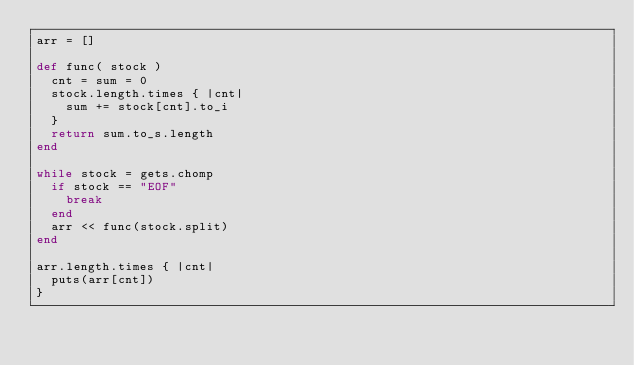<code> <loc_0><loc_0><loc_500><loc_500><_Ruby_>arr = []

def func( stock )
  cnt = sum = 0
  stock.length.times { |cnt|
    sum += stock[cnt].to_i
  }
  return sum.to_s.length
end

while stock = gets.chomp
  if stock == "EOF"
    break
  end
  arr << func(stock.split)
end

arr.length.times { |cnt|
  puts(arr[cnt])
}</code> 